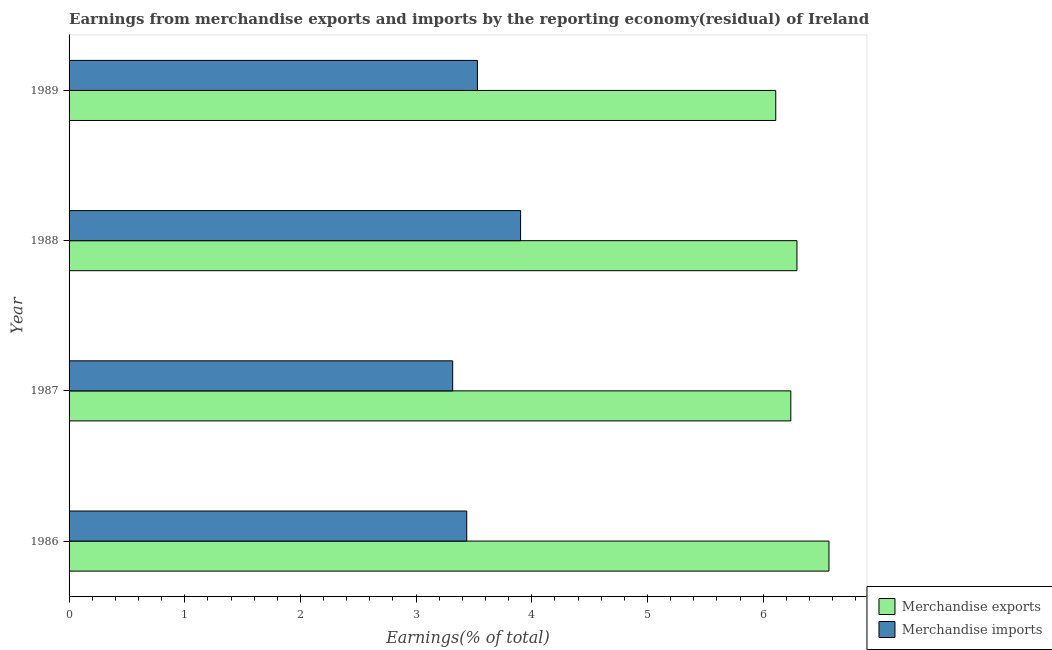How many different coloured bars are there?
Offer a terse response. 2. How many groups of bars are there?
Keep it short and to the point. 4. Are the number of bars on each tick of the Y-axis equal?
Make the answer very short. Yes. How many bars are there on the 4th tick from the top?
Provide a succinct answer. 2. How many bars are there on the 1st tick from the bottom?
Ensure brevity in your answer.  2. What is the earnings from merchandise imports in 1988?
Provide a short and direct response. 3.9. Across all years, what is the maximum earnings from merchandise exports?
Your response must be concise. 6.57. Across all years, what is the minimum earnings from merchandise exports?
Offer a terse response. 6.11. In which year was the earnings from merchandise exports maximum?
Provide a succinct answer. 1986. What is the total earnings from merchandise exports in the graph?
Your answer should be very brief. 25.21. What is the difference between the earnings from merchandise exports in 1986 and that in 1988?
Provide a short and direct response. 0.28. What is the difference between the earnings from merchandise exports in 1987 and the earnings from merchandise imports in 1989?
Keep it short and to the point. 2.71. What is the average earnings from merchandise exports per year?
Offer a terse response. 6.3. In the year 1989, what is the difference between the earnings from merchandise exports and earnings from merchandise imports?
Keep it short and to the point. 2.58. Is the earnings from merchandise imports in 1986 less than that in 1989?
Provide a succinct answer. Yes. What is the difference between the highest and the second highest earnings from merchandise exports?
Make the answer very short. 0.28. What is the difference between the highest and the lowest earnings from merchandise exports?
Your answer should be very brief. 0.46. In how many years, is the earnings from merchandise exports greater than the average earnings from merchandise exports taken over all years?
Offer a terse response. 1. Is the sum of the earnings from merchandise imports in 1987 and 1988 greater than the maximum earnings from merchandise exports across all years?
Provide a short and direct response. Yes. What does the 1st bar from the top in 1988 represents?
Keep it short and to the point. Merchandise imports. How many years are there in the graph?
Your response must be concise. 4. Does the graph contain grids?
Offer a terse response. No. Where does the legend appear in the graph?
Your response must be concise. Bottom right. How many legend labels are there?
Keep it short and to the point. 2. What is the title of the graph?
Provide a succinct answer. Earnings from merchandise exports and imports by the reporting economy(residual) of Ireland. What is the label or title of the X-axis?
Provide a succinct answer. Earnings(% of total). What is the label or title of the Y-axis?
Your answer should be very brief. Year. What is the Earnings(% of total) of Merchandise exports in 1986?
Your answer should be very brief. 6.57. What is the Earnings(% of total) of Merchandise imports in 1986?
Your answer should be very brief. 3.44. What is the Earnings(% of total) in Merchandise exports in 1987?
Provide a succinct answer. 6.24. What is the Earnings(% of total) of Merchandise imports in 1987?
Your response must be concise. 3.32. What is the Earnings(% of total) of Merchandise exports in 1988?
Offer a terse response. 6.29. What is the Earnings(% of total) in Merchandise imports in 1988?
Keep it short and to the point. 3.9. What is the Earnings(% of total) in Merchandise exports in 1989?
Make the answer very short. 6.11. What is the Earnings(% of total) in Merchandise imports in 1989?
Your response must be concise. 3.53. Across all years, what is the maximum Earnings(% of total) in Merchandise exports?
Offer a terse response. 6.57. Across all years, what is the maximum Earnings(% of total) in Merchandise imports?
Offer a terse response. 3.9. Across all years, what is the minimum Earnings(% of total) of Merchandise exports?
Your response must be concise. 6.11. Across all years, what is the minimum Earnings(% of total) in Merchandise imports?
Your answer should be compact. 3.32. What is the total Earnings(% of total) in Merchandise exports in the graph?
Your answer should be very brief. 25.21. What is the total Earnings(% of total) of Merchandise imports in the graph?
Offer a terse response. 14.19. What is the difference between the Earnings(% of total) in Merchandise exports in 1986 and that in 1987?
Offer a very short reply. 0.33. What is the difference between the Earnings(% of total) in Merchandise imports in 1986 and that in 1987?
Provide a succinct answer. 0.12. What is the difference between the Earnings(% of total) of Merchandise exports in 1986 and that in 1988?
Provide a short and direct response. 0.28. What is the difference between the Earnings(% of total) of Merchandise imports in 1986 and that in 1988?
Offer a very short reply. -0.47. What is the difference between the Earnings(% of total) in Merchandise exports in 1986 and that in 1989?
Keep it short and to the point. 0.46. What is the difference between the Earnings(% of total) in Merchandise imports in 1986 and that in 1989?
Keep it short and to the point. -0.09. What is the difference between the Earnings(% of total) in Merchandise exports in 1987 and that in 1988?
Your response must be concise. -0.05. What is the difference between the Earnings(% of total) of Merchandise imports in 1987 and that in 1988?
Ensure brevity in your answer.  -0.59. What is the difference between the Earnings(% of total) of Merchandise exports in 1987 and that in 1989?
Provide a succinct answer. 0.13. What is the difference between the Earnings(% of total) of Merchandise imports in 1987 and that in 1989?
Make the answer very short. -0.21. What is the difference between the Earnings(% of total) in Merchandise exports in 1988 and that in 1989?
Provide a short and direct response. 0.18. What is the difference between the Earnings(% of total) of Merchandise imports in 1988 and that in 1989?
Ensure brevity in your answer.  0.37. What is the difference between the Earnings(% of total) in Merchandise exports in 1986 and the Earnings(% of total) in Merchandise imports in 1987?
Your response must be concise. 3.25. What is the difference between the Earnings(% of total) in Merchandise exports in 1986 and the Earnings(% of total) in Merchandise imports in 1988?
Your answer should be compact. 2.67. What is the difference between the Earnings(% of total) of Merchandise exports in 1986 and the Earnings(% of total) of Merchandise imports in 1989?
Offer a terse response. 3.04. What is the difference between the Earnings(% of total) of Merchandise exports in 1987 and the Earnings(% of total) of Merchandise imports in 1988?
Offer a very short reply. 2.34. What is the difference between the Earnings(% of total) in Merchandise exports in 1987 and the Earnings(% of total) in Merchandise imports in 1989?
Your response must be concise. 2.71. What is the difference between the Earnings(% of total) in Merchandise exports in 1988 and the Earnings(% of total) in Merchandise imports in 1989?
Keep it short and to the point. 2.76. What is the average Earnings(% of total) in Merchandise exports per year?
Ensure brevity in your answer.  6.3. What is the average Earnings(% of total) in Merchandise imports per year?
Provide a short and direct response. 3.55. In the year 1986, what is the difference between the Earnings(% of total) in Merchandise exports and Earnings(% of total) in Merchandise imports?
Provide a short and direct response. 3.13. In the year 1987, what is the difference between the Earnings(% of total) in Merchandise exports and Earnings(% of total) in Merchandise imports?
Your answer should be very brief. 2.92. In the year 1988, what is the difference between the Earnings(% of total) of Merchandise exports and Earnings(% of total) of Merchandise imports?
Offer a terse response. 2.39. In the year 1989, what is the difference between the Earnings(% of total) in Merchandise exports and Earnings(% of total) in Merchandise imports?
Offer a very short reply. 2.58. What is the ratio of the Earnings(% of total) of Merchandise exports in 1986 to that in 1987?
Keep it short and to the point. 1.05. What is the ratio of the Earnings(% of total) of Merchandise imports in 1986 to that in 1987?
Provide a succinct answer. 1.04. What is the ratio of the Earnings(% of total) of Merchandise exports in 1986 to that in 1988?
Offer a terse response. 1.04. What is the ratio of the Earnings(% of total) in Merchandise imports in 1986 to that in 1988?
Ensure brevity in your answer.  0.88. What is the ratio of the Earnings(% of total) of Merchandise exports in 1986 to that in 1989?
Provide a succinct answer. 1.08. What is the ratio of the Earnings(% of total) of Merchandise imports in 1986 to that in 1989?
Provide a succinct answer. 0.97. What is the ratio of the Earnings(% of total) of Merchandise exports in 1987 to that in 1988?
Offer a terse response. 0.99. What is the ratio of the Earnings(% of total) of Merchandise imports in 1987 to that in 1988?
Offer a terse response. 0.85. What is the ratio of the Earnings(% of total) of Merchandise exports in 1987 to that in 1989?
Provide a short and direct response. 1.02. What is the ratio of the Earnings(% of total) of Merchandise imports in 1987 to that in 1989?
Your answer should be very brief. 0.94. What is the ratio of the Earnings(% of total) in Merchandise exports in 1988 to that in 1989?
Give a very brief answer. 1.03. What is the ratio of the Earnings(% of total) in Merchandise imports in 1988 to that in 1989?
Make the answer very short. 1.11. What is the difference between the highest and the second highest Earnings(% of total) of Merchandise exports?
Your answer should be very brief. 0.28. What is the difference between the highest and the second highest Earnings(% of total) of Merchandise imports?
Keep it short and to the point. 0.37. What is the difference between the highest and the lowest Earnings(% of total) of Merchandise exports?
Keep it short and to the point. 0.46. What is the difference between the highest and the lowest Earnings(% of total) in Merchandise imports?
Your response must be concise. 0.59. 